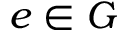Convert formula to latex. <formula><loc_0><loc_0><loc_500><loc_500>e \in G</formula> 